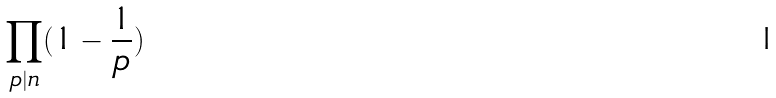Convert formula to latex. <formula><loc_0><loc_0><loc_500><loc_500>\prod _ { p | n } ( 1 - \frac { 1 } { p } )</formula> 